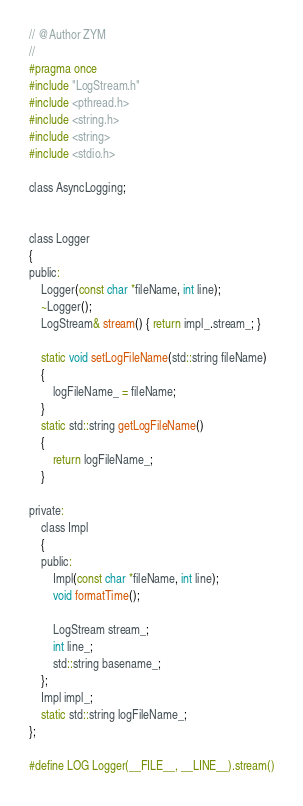<code> <loc_0><loc_0><loc_500><loc_500><_C_>// @Author ZYM
//
#pragma once
#include "LogStream.h"
#include <pthread.h>
#include <string.h>
#include <string>
#include <stdio.h>

class AsyncLogging;


class Logger
{
public:
    Logger(const char *fileName, int line);
    ~Logger();
    LogStream& stream() { return impl_.stream_; }

    static void setLogFileName(std::string fileName)
    {
        logFileName_ = fileName;
    }
    static std::string getLogFileName()
    {
        return logFileName_;
    }

private:
    class Impl
    {
    public:
        Impl(const char *fileName, int line);
        void formatTime();

        LogStream stream_;
        int line_;
        std::string basename_;
    };
    Impl impl_;
    static std::string logFileName_;
};

#define LOG Logger(__FILE__, __LINE__).stream()</code> 